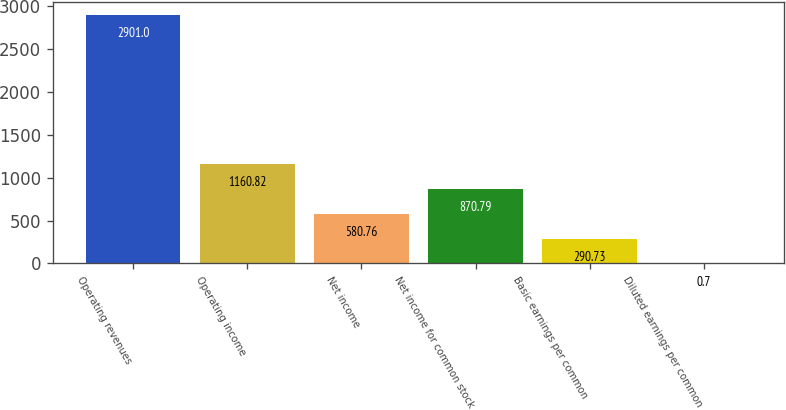Convert chart. <chart><loc_0><loc_0><loc_500><loc_500><bar_chart><fcel>Operating revenues<fcel>Operating income<fcel>Net income<fcel>Net income for common stock<fcel>Basic earnings per common<fcel>Diluted earnings per common<nl><fcel>2901<fcel>1160.82<fcel>580.76<fcel>870.79<fcel>290.73<fcel>0.7<nl></chart> 